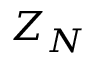<formula> <loc_0><loc_0><loc_500><loc_500>Z _ { N }</formula> 